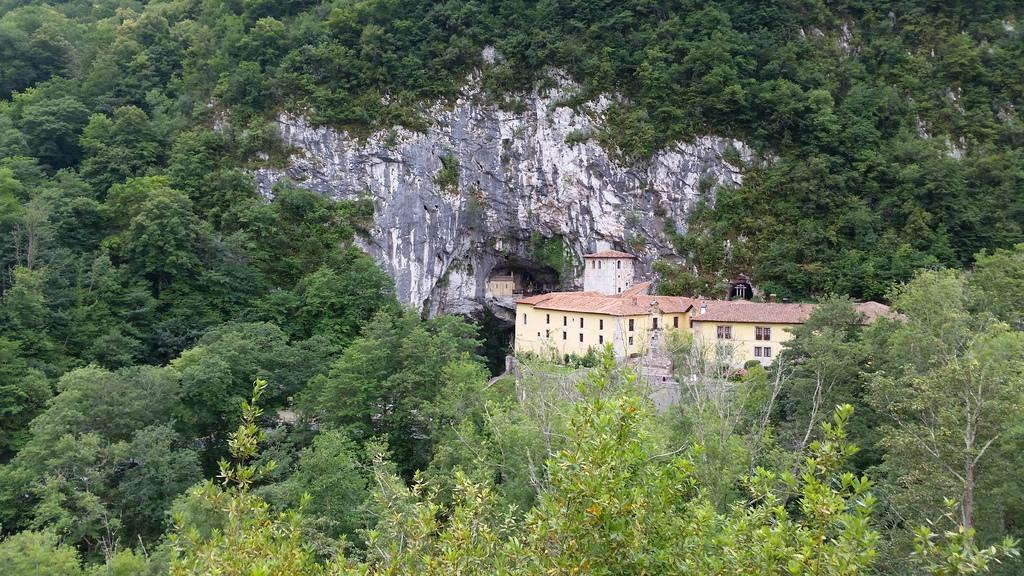What type of structures are present in the image? There are buildings in the image. What color are the buildings? The buildings are in a light yellow color. What can be seen in the background of the image? There are trees in the background of the image. What color are the trees? The trees are in a green color. What type of letter is being delivered by the metal carriage in the image? There is no letter or carriage present in the image; it only features buildings and trees. 